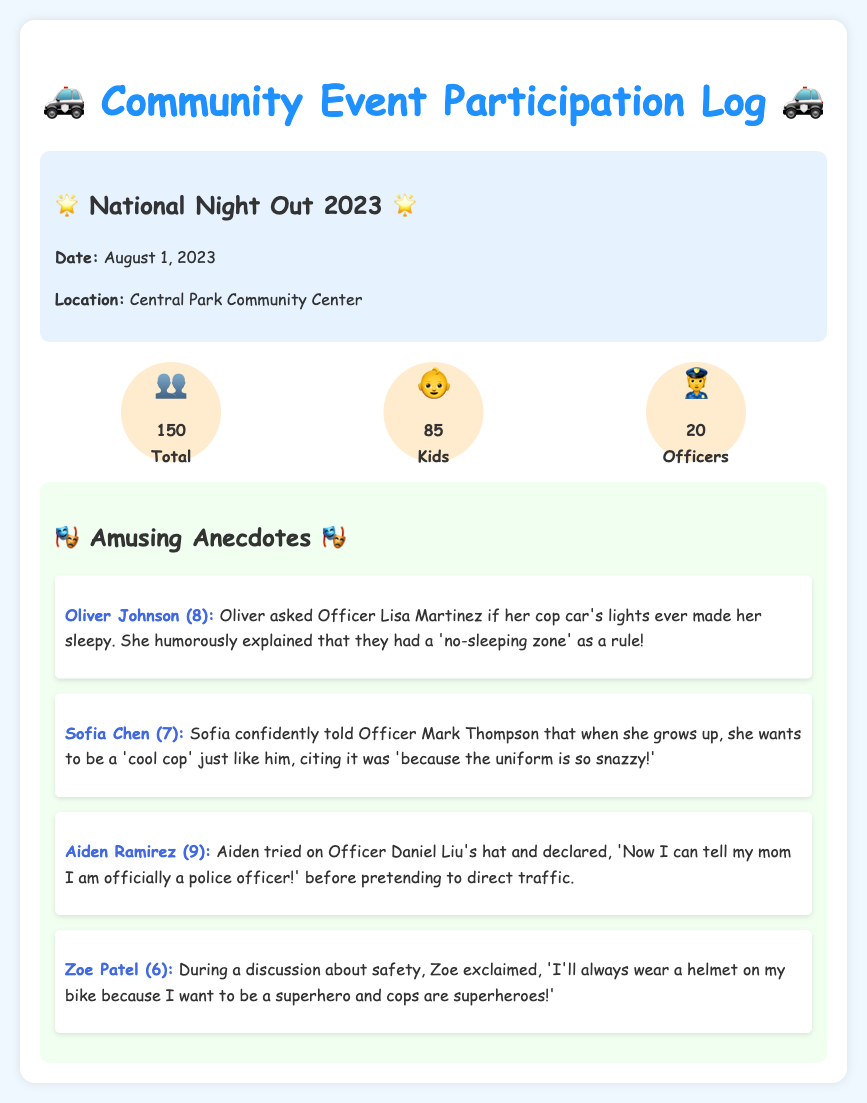What was the date of the event? The date of the event is mentioned in the event details section of the document.
Answer: August 1, 2023 How many kids attended the event? The number of kids is listed in the attendance section of the document.
Answer: 85 Who is the officer that Oliver Johnson interacted with? The name of the officer is specified in the anecdote about Oliver Johnson.
Answer: Officer Lisa Martinez What did Aiden Ramirez declare after trying on the hat? Aiden's declaration is quoted in his anecdote.
Answer: Now I can tell my mom I am officially a police officer! What is the total attendance at the event? The total attendance is recorded in the attendance section as the sum of all attendees.
Answer: 150 Which child wanted to be a 'cool cop'? The child's aspiration is mentioned in Sofia's anecdote.
Answer: Sofia Chen Why did Zoe Patel say she would wear a helmet? The reason is explained in her anecdote about safety.
Answer: Because I want to be a superhero and cops are superheroes! What was the location of the event? The event's location is provided in the event details section.
Answer: Central Park Community Center 